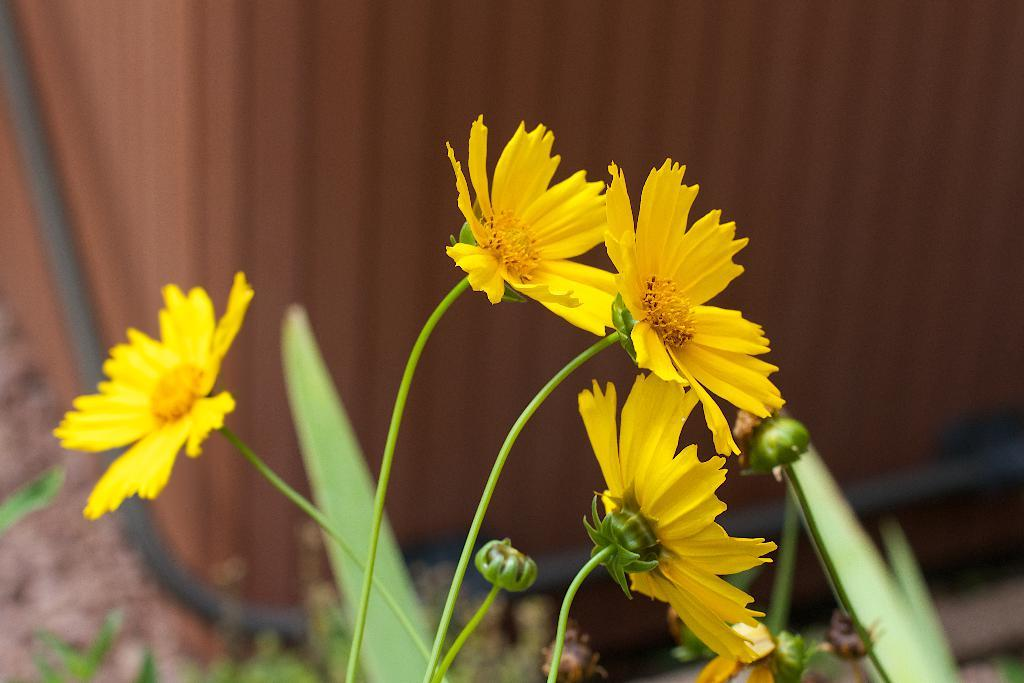What type of plants can be seen in the image? There are flowers in the image. Can you describe the structure of the flowers? The flowers have stems. How many pieces of lumber are stacked next to the flowers in the image? There is no lumber present in the image; it only features flowers with stems. What type of chess piece can be seen on the petals of the flowers? There are no chess pieces present on the flowers in the image. 